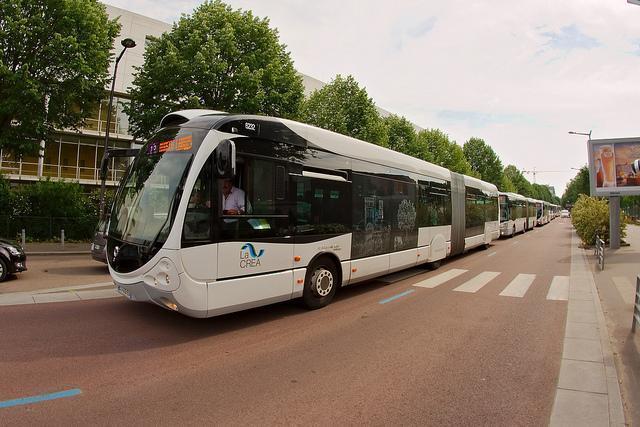How many white wide stripes is there?
Give a very brief answer. 4. 